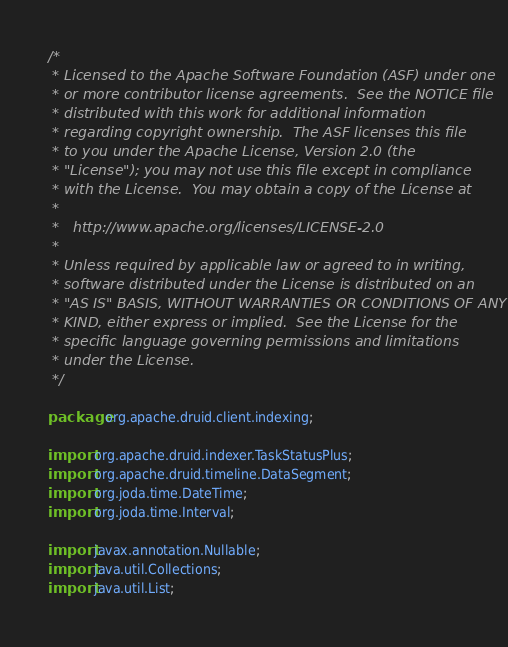Convert code to text. <code><loc_0><loc_0><loc_500><loc_500><_Java_>/*
 * Licensed to the Apache Software Foundation (ASF) under one
 * or more contributor license agreements.  See the NOTICE file
 * distributed with this work for additional information
 * regarding copyright ownership.  The ASF licenses this file
 * to you under the Apache License, Version 2.0 (the
 * "License"); you may not use this file except in compliance
 * with the License.  You may obtain a copy of the License at
 *
 *   http://www.apache.org/licenses/LICENSE-2.0
 *
 * Unless required by applicable law or agreed to in writing,
 * software distributed under the License is distributed on an
 * "AS IS" BASIS, WITHOUT WARRANTIES OR CONDITIONS OF ANY
 * KIND, either express or implied.  See the License for the
 * specific language governing permissions and limitations
 * under the License.
 */

package org.apache.druid.client.indexing;

import org.apache.druid.indexer.TaskStatusPlus;
import org.apache.druid.timeline.DataSegment;
import org.joda.time.DateTime;
import org.joda.time.Interval;

import javax.annotation.Nullable;
import java.util.Collections;
import java.util.List;</code> 